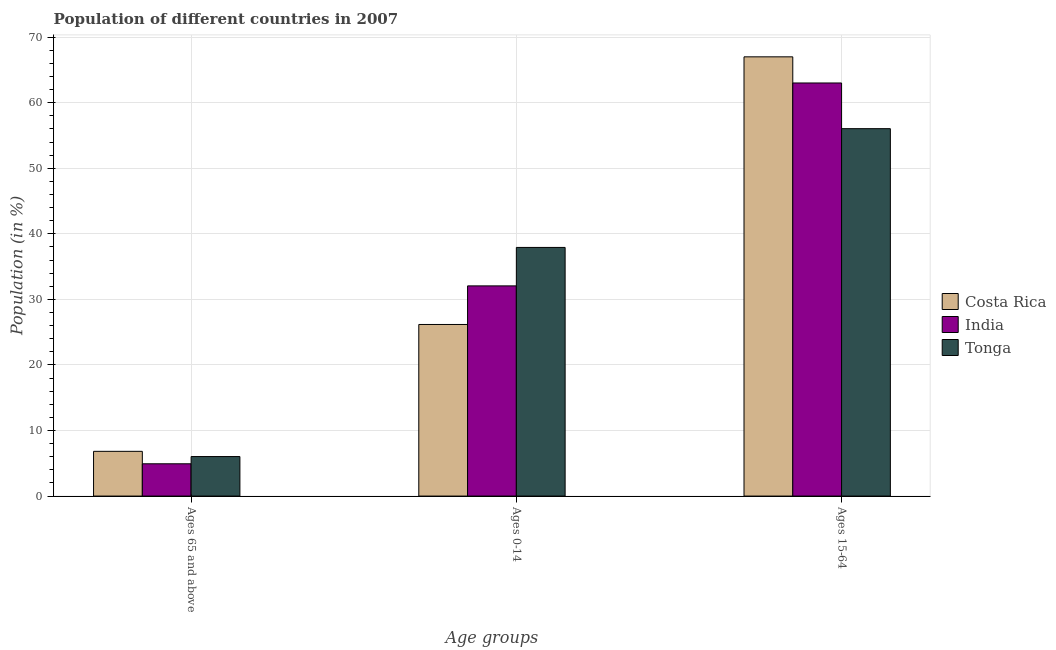How many groups of bars are there?
Provide a short and direct response. 3. Are the number of bars on each tick of the X-axis equal?
Offer a very short reply. Yes. How many bars are there on the 2nd tick from the left?
Keep it short and to the point. 3. What is the label of the 2nd group of bars from the left?
Offer a terse response. Ages 0-14. What is the percentage of population within the age-group of 65 and above in India?
Provide a short and direct response. 4.92. Across all countries, what is the maximum percentage of population within the age-group 15-64?
Your answer should be very brief. 67. Across all countries, what is the minimum percentage of population within the age-group 0-14?
Your answer should be very brief. 26.18. In which country was the percentage of population within the age-group 0-14 maximum?
Make the answer very short. Tonga. What is the total percentage of population within the age-group of 65 and above in the graph?
Ensure brevity in your answer.  17.77. What is the difference between the percentage of population within the age-group of 65 and above in Tonga and that in India?
Give a very brief answer. 1.1. What is the difference between the percentage of population within the age-group 15-64 in Costa Rica and the percentage of population within the age-group 0-14 in Tonga?
Offer a very short reply. 29.07. What is the average percentage of population within the age-group 0-14 per country?
Offer a terse response. 32.05. What is the difference between the percentage of population within the age-group 0-14 and percentage of population within the age-group 15-64 in Tonga?
Your answer should be very brief. -18.12. In how many countries, is the percentage of population within the age-group 15-64 greater than 68 %?
Offer a terse response. 0. What is the ratio of the percentage of population within the age-group 15-64 in India to that in Costa Rica?
Offer a very short reply. 0.94. Is the percentage of population within the age-group 0-14 in Tonga less than that in Costa Rica?
Offer a terse response. No. What is the difference between the highest and the second highest percentage of population within the age-group 15-64?
Your answer should be compact. 3.99. What is the difference between the highest and the lowest percentage of population within the age-group of 65 and above?
Your answer should be very brief. 1.9. Is the sum of the percentage of population within the age-group 15-64 in India and Tonga greater than the maximum percentage of population within the age-group 0-14 across all countries?
Keep it short and to the point. Yes. What does the 1st bar from the left in Ages 15-64 represents?
Your response must be concise. Costa Rica. What does the 2nd bar from the right in Ages 15-64 represents?
Offer a terse response. India. Does the graph contain grids?
Make the answer very short. Yes. How many legend labels are there?
Provide a succinct answer. 3. What is the title of the graph?
Your answer should be compact. Population of different countries in 2007. What is the label or title of the X-axis?
Offer a terse response. Age groups. What is the Population (in %) in Costa Rica in Ages 65 and above?
Provide a short and direct response. 6.82. What is the Population (in %) of India in Ages 65 and above?
Your response must be concise. 4.92. What is the Population (in %) in Tonga in Ages 65 and above?
Your answer should be very brief. 6.03. What is the Population (in %) of Costa Rica in Ages 0-14?
Your response must be concise. 26.18. What is the Population (in %) in India in Ages 0-14?
Give a very brief answer. 32.06. What is the Population (in %) of Tonga in Ages 0-14?
Make the answer very short. 37.93. What is the Population (in %) in Costa Rica in Ages 15-64?
Provide a short and direct response. 67. What is the Population (in %) of India in Ages 15-64?
Offer a very short reply. 63.01. What is the Population (in %) of Tonga in Ages 15-64?
Ensure brevity in your answer.  56.05. Across all Age groups, what is the maximum Population (in %) of Costa Rica?
Ensure brevity in your answer.  67. Across all Age groups, what is the maximum Population (in %) in India?
Your answer should be compact. 63.01. Across all Age groups, what is the maximum Population (in %) of Tonga?
Your answer should be compact. 56.05. Across all Age groups, what is the minimum Population (in %) in Costa Rica?
Your answer should be very brief. 6.82. Across all Age groups, what is the minimum Population (in %) of India?
Give a very brief answer. 4.92. Across all Age groups, what is the minimum Population (in %) in Tonga?
Your answer should be very brief. 6.03. What is the difference between the Population (in %) in Costa Rica in Ages 65 and above and that in Ages 0-14?
Offer a very short reply. -19.35. What is the difference between the Population (in %) in India in Ages 65 and above and that in Ages 0-14?
Your answer should be compact. -27.14. What is the difference between the Population (in %) of Tonga in Ages 65 and above and that in Ages 0-14?
Make the answer very short. -31.9. What is the difference between the Population (in %) of Costa Rica in Ages 65 and above and that in Ages 15-64?
Give a very brief answer. -60.18. What is the difference between the Population (in %) in India in Ages 65 and above and that in Ages 15-64?
Make the answer very short. -58.09. What is the difference between the Population (in %) in Tonga in Ages 65 and above and that in Ages 15-64?
Provide a succinct answer. -50.02. What is the difference between the Population (in %) of Costa Rica in Ages 0-14 and that in Ages 15-64?
Ensure brevity in your answer.  -40.83. What is the difference between the Population (in %) of India in Ages 0-14 and that in Ages 15-64?
Offer a terse response. -30.95. What is the difference between the Population (in %) in Tonga in Ages 0-14 and that in Ages 15-64?
Give a very brief answer. -18.12. What is the difference between the Population (in %) of Costa Rica in Ages 65 and above and the Population (in %) of India in Ages 0-14?
Ensure brevity in your answer.  -25.24. What is the difference between the Population (in %) in Costa Rica in Ages 65 and above and the Population (in %) in Tonga in Ages 0-14?
Your response must be concise. -31.11. What is the difference between the Population (in %) in India in Ages 65 and above and the Population (in %) in Tonga in Ages 0-14?
Give a very brief answer. -33. What is the difference between the Population (in %) of Costa Rica in Ages 65 and above and the Population (in %) of India in Ages 15-64?
Ensure brevity in your answer.  -56.19. What is the difference between the Population (in %) in Costa Rica in Ages 65 and above and the Population (in %) in Tonga in Ages 15-64?
Ensure brevity in your answer.  -49.22. What is the difference between the Population (in %) of India in Ages 65 and above and the Population (in %) of Tonga in Ages 15-64?
Provide a short and direct response. -51.12. What is the difference between the Population (in %) in Costa Rica in Ages 0-14 and the Population (in %) in India in Ages 15-64?
Your answer should be compact. -36.84. What is the difference between the Population (in %) in Costa Rica in Ages 0-14 and the Population (in %) in Tonga in Ages 15-64?
Make the answer very short. -29.87. What is the difference between the Population (in %) of India in Ages 0-14 and the Population (in %) of Tonga in Ages 15-64?
Your answer should be compact. -23.98. What is the average Population (in %) of Costa Rica per Age groups?
Your answer should be very brief. 33.33. What is the average Population (in %) in India per Age groups?
Give a very brief answer. 33.33. What is the average Population (in %) in Tonga per Age groups?
Give a very brief answer. 33.33. What is the difference between the Population (in %) in Costa Rica and Population (in %) in India in Ages 65 and above?
Offer a very short reply. 1.9. What is the difference between the Population (in %) in Costa Rica and Population (in %) in Tonga in Ages 65 and above?
Your answer should be very brief. 0.8. What is the difference between the Population (in %) in India and Population (in %) in Tonga in Ages 65 and above?
Your answer should be compact. -1.1. What is the difference between the Population (in %) of Costa Rica and Population (in %) of India in Ages 0-14?
Give a very brief answer. -5.89. What is the difference between the Population (in %) in Costa Rica and Population (in %) in Tonga in Ages 0-14?
Ensure brevity in your answer.  -11.75. What is the difference between the Population (in %) of India and Population (in %) of Tonga in Ages 0-14?
Give a very brief answer. -5.87. What is the difference between the Population (in %) of Costa Rica and Population (in %) of India in Ages 15-64?
Offer a very short reply. 3.99. What is the difference between the Population (in %) in Costa Rica and Population (in %) in Tonga in Ages 15-64?
Ensure brevity in your answer.  10.96. What is the difference between the Population (in %) in India and Population (in %) in Tonga in Ages 15-64?
Provide a succinct answer. 6.97. What is the ratio of the Population (in %) in Costa Rica in Ages 65 and above to that in Ages 0-14?
Provide a short and direct response. 0.26. What is the ratio of the Population (in %) in India in Ages 65 and above to that in Ages 0-14?
Keep it short and to the point. 0.15. What is the ratio of the Population (in %) in Tonga in Ages 65 and above to that in Ages 0-14?
Ensure brevity in your answer.  0.16. What is the ratio of the Population (in %) of Costa Rica in Ages 65 and above to that in Ages 15-64?
Ensure brevity in your answer.  0.1. What is the ratio of the Population (in %) of India in Ages 65 and above to that in Ages 15-64?
Your response must be concise. 0.08. What is the ratio of the Population (in %) in Tonga in Ages 65 and above to that in Ages 15-64?
Your response must be concise. 0.11. What is the ratio of the Population (in %) in Costa Rica in Ages 0-14 to that in Ages 15-64?
Give a very brief answer. 0.39. What is the ratio of the Population (in %) in India in Ages 0-14 to that in Ages 15-64?
Ensure brevity in your answer.  0.51. What is the ratio of the Population (in %) of Tonga in Ages 0-14 to that in Ages 15-64?
Give a very brief answer. 0.68. What is the difference between the highest and the second highest Population (in %) in Costa Rica?
Make the answer very short. 40.83. What is the difference between the highest and the second highest Population (in %) in India?
Offer a terse response. 30.95. What is the difference between the highest and the second highest Population (in %) in Tonga?
Provide a short and direct response. 18.12. What is the difference between the highest and the lowest Population (in %) of Costa Rica?
Your response must be concise. 60.18. What is the difference between the highest and the lowest Population (in %) of India?
Your response must be concise. 58.09. What is the difference between the highest and the lowest Population (in %) of Tonga?
Keep it short and to the point. 50.02. 